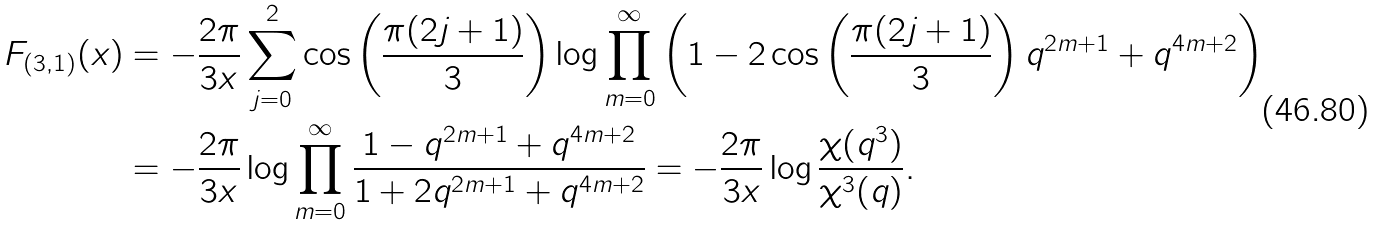<formula> <loc_0><loc_0><loc_500><loc_500>F _ { ( 3 , 1 ) } ( x ) & = - \frac { 2 \pi } { 3 x } \sum _ { j = 0 } ^ { 2 } \cos \left ( \frac { \pi ( 2 j + 1 ) } { 3 } \right ) \log \prod _ { m = 0 } ^ { \infty } \left ( 1 - 2 \cos \left ( \frac { \pi ( 2 j + 1 ) } { 3 } \right ) q ^ { 2 m + 1 } + q ^ { 4 m + 2 } \right ) \\ & = - \frac { 2 \pi } { 3 x } \log \prod _ { m = 0 } ^ { \infty } \frac { 1 - q ^ { 2 m + 1 } + q ^ { 4 m + 2 } } { 1 + 2 q ^ { 2 m + 1 } + q ^ { 4 m + 2 } } = - \frac { 2 \pi } { 3 x } \log \frac { \chi ( q ^ { 3 } ) } { \chi ^ { 3 } ( q ) } .</formula> 